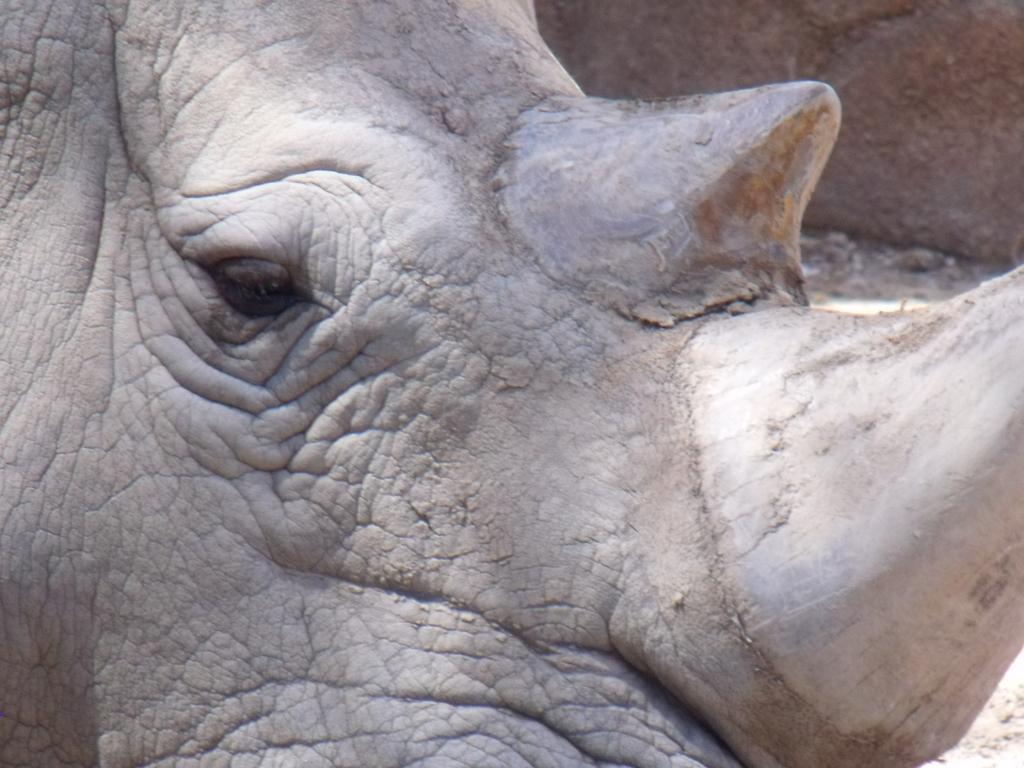How would you summarize this image in a sentence or two? In the background we can see the wall. This picture is mainly highlighted with the partial part of a rhinoceros. 